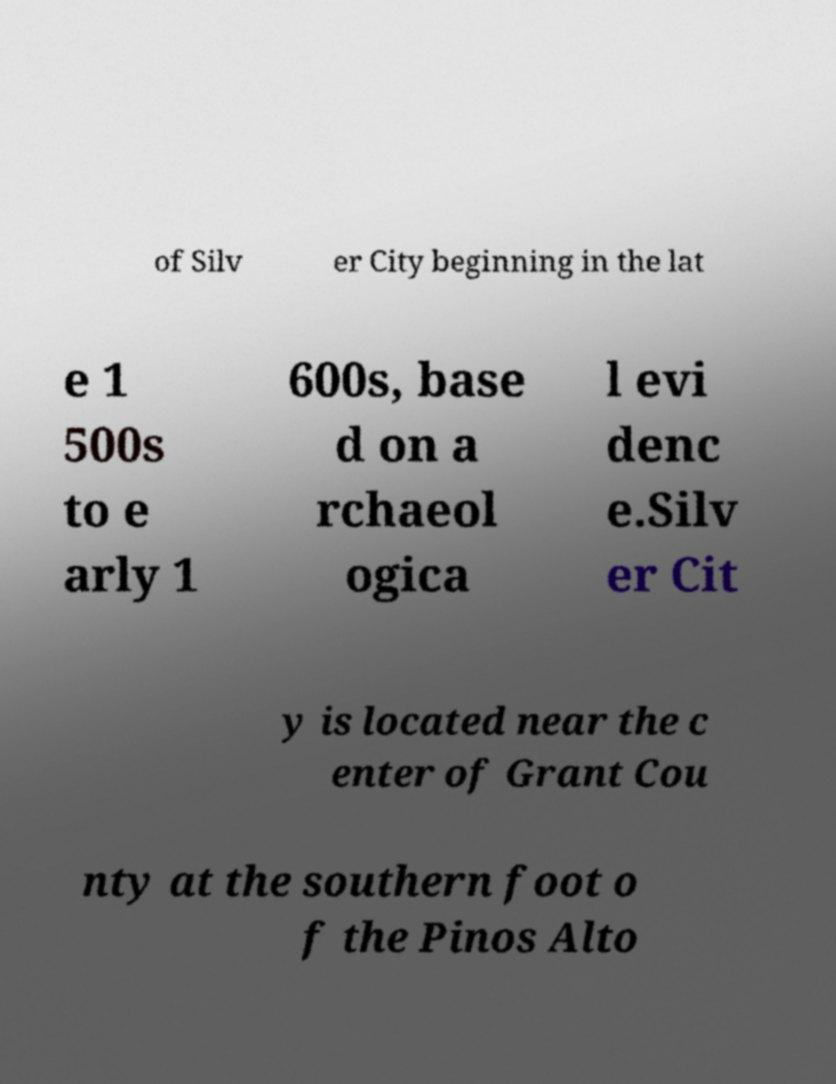There's text embedded in this image that I need extracted. Can you transcribe it verbatim? of Silv er City beginning in the lat e 1 500s to e arly 1 600s, base d on a rchaeol ogica l evi denc e.Silv er Cit y is located near the c enter of Grant Cou nty at the southern foot o f the Pinos Alto 